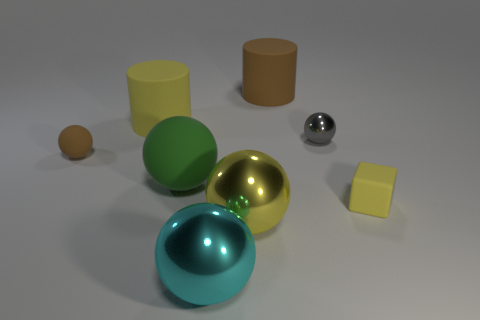What is the material of the green thing that is the same shape as the yellow metal thing?
Keep it short and to the point. Rubber. What is the shape of the small rubber thing right of the large rubber thing that is on the right side of the big yellow thing that is in front of the small metallic ball?
Provide a succinct answer. Cube. Are there more large yellow shiny things to the right of the yellow metal ball than large green things?
Ensure brevity in your answer.  No. Does the big yellow object that is behind the small gray metal sphere have the same shape as the green matte thing?
Provide a short and direct response. No. What is the material of the small thing behind the brown matte sphere?
Make the answer very short. Metal. What number of other big cyan metal objects are the same shape as the large cyan object?
Provide a short and direct response. 0. There is a tiny sphere on the right side of the large rubber thing on the right side of the cyan metal object; what is it made of?
Keep it short and to the point. Metal. There is a rubber thing that is the same color as the small rubber cube; what shape is it?
Ensure brevity in your answer.  Cylinder. Is there another thing made of the same material as the big cyan thing?
Provide a short and direct response. Yes. What is the shape of the green matte thing?
Keep it short and to the point. Sphere. 